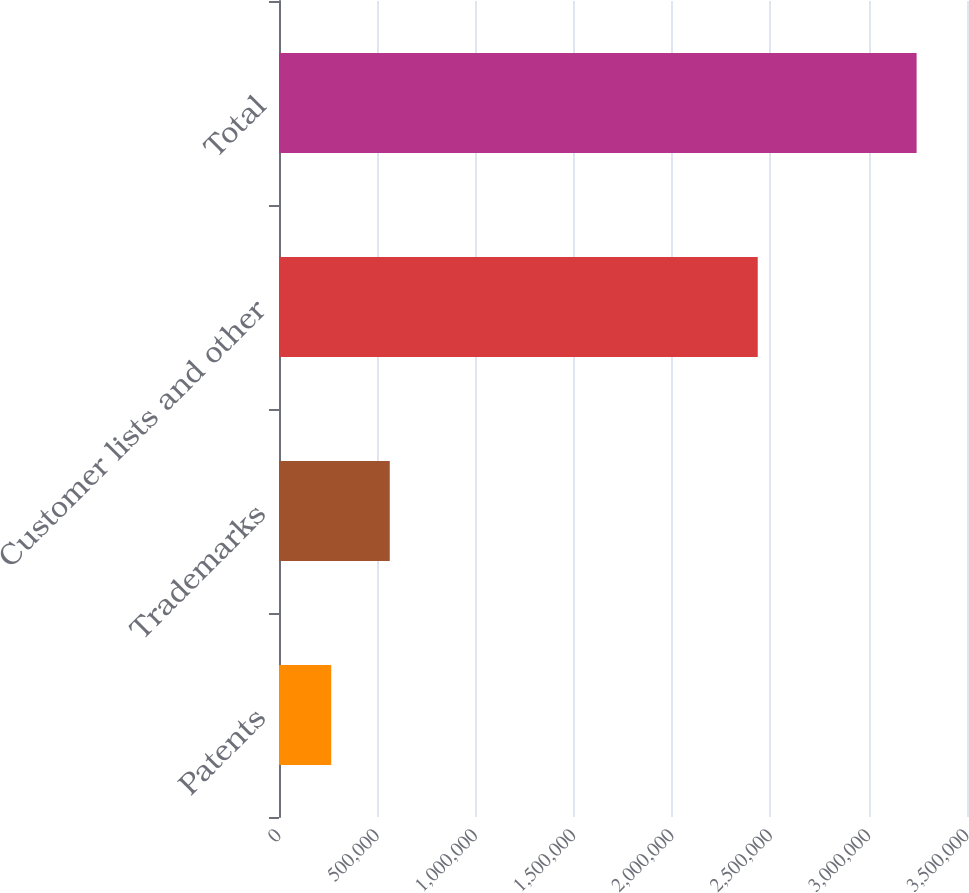Convert chart to OTSL. <chart><loc_0><loc_0><loc_500><loc_500><bar_chart><fcel>Patents<fcel>Trademarks<fcel>Customer lists and other<fcel>Total<nl><fcel>265644<fcel>563447<fcel>2.43546e+06<fcel>3.24368e+06<nl></chart> 